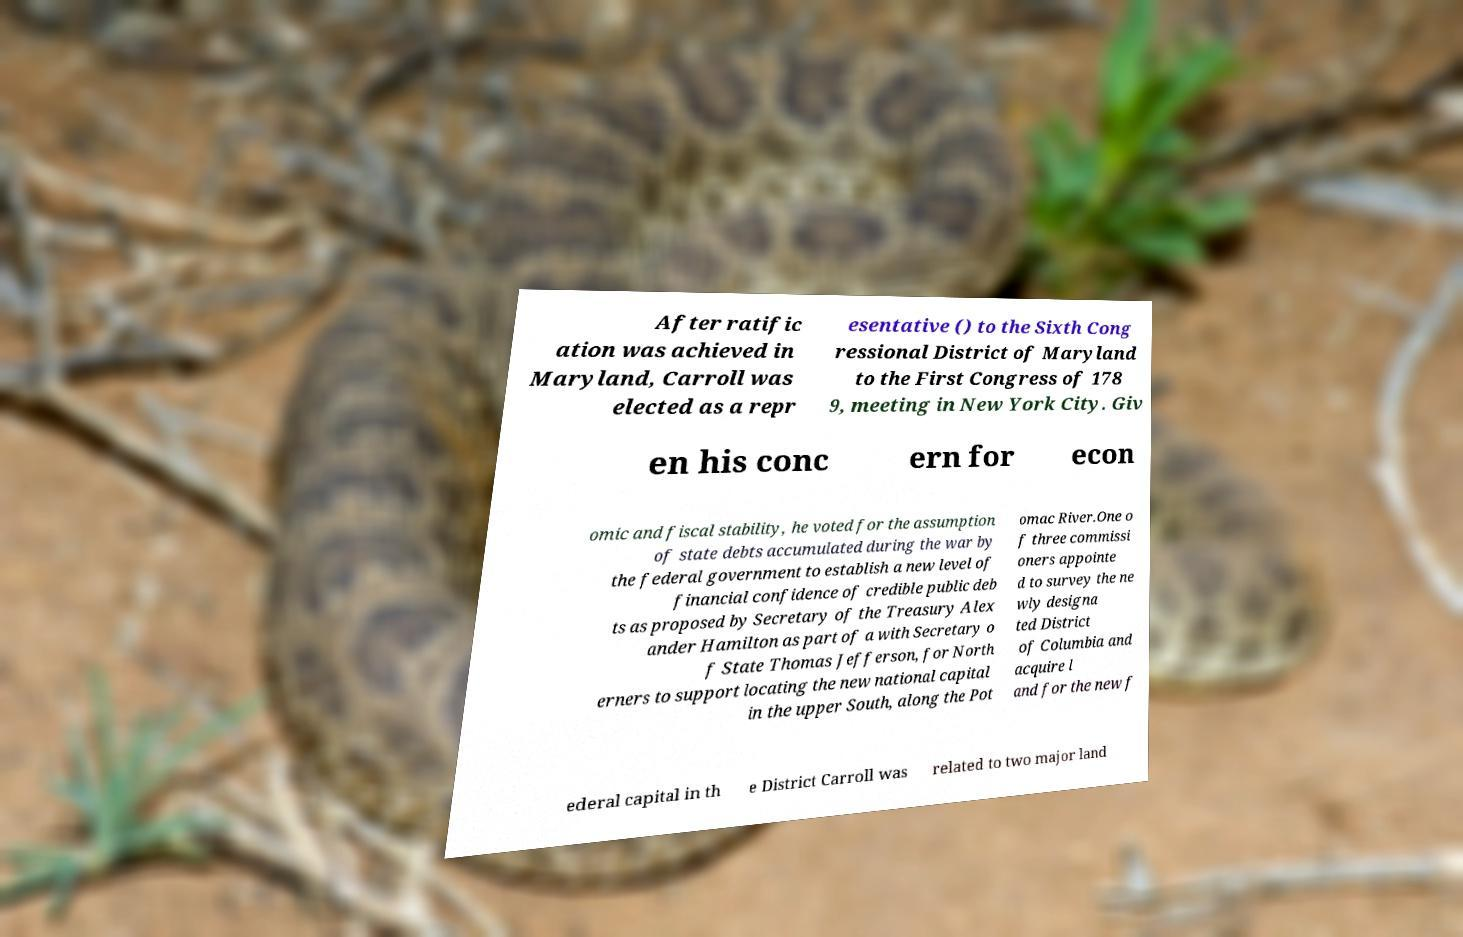There's text embedded in this image that I need extracted. Can you transcribe it verbatim? After ratific ation was achieved in Maryland, Carroll was elected as a repr esentative () to the Sixth Cong ressional District of Maryland to the First Congress of 178 9, meeting in New York City. Giv en his conc ern for econ omic and fiscal stability, he voted for the assumption of state debts accumulated during the war by the federal government to establish a new level of financial confidence of credible public deb ts as proposed by Secretary of the Treasury Alex ander Hamilton as part of a with Secretary o f State Thomas Jefferson, for North erners to support locating the new national capital in the upper South, along the Pot omac River.One o f three commissi oners appointe d to survey the ne wly designa ted District of Columbia and acquire l and for the new f ederal capital in th e District Carroll was related to two major land 